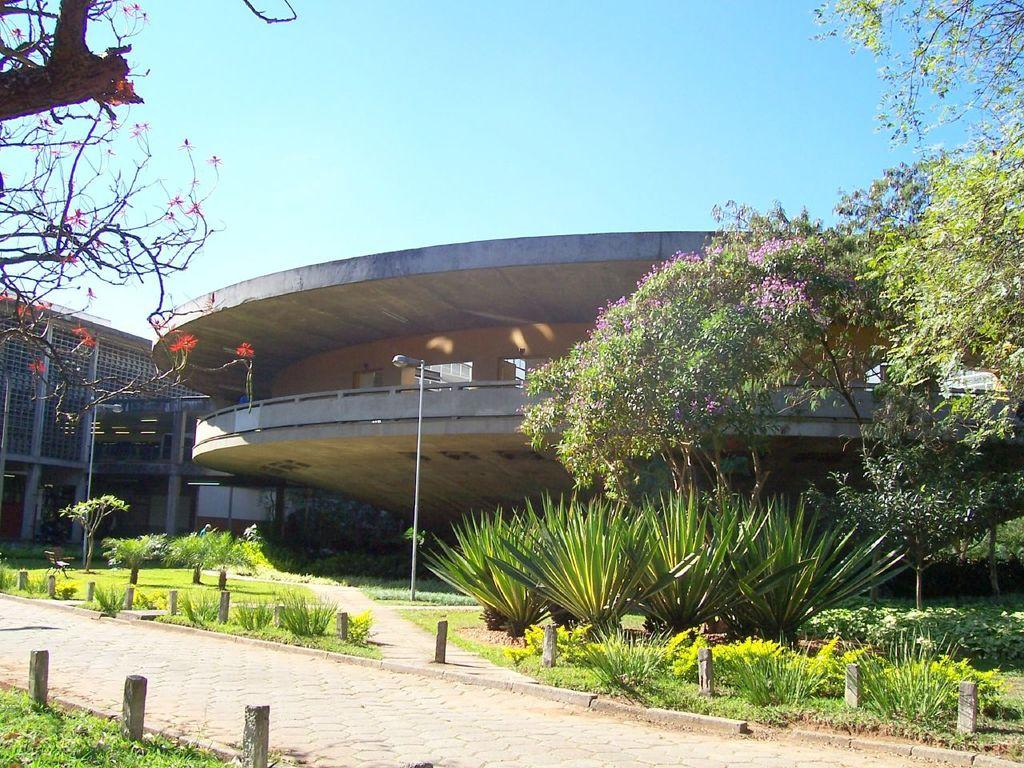What type of vegetation can be seen in the image? There is grass, plants, trees, and flowers in the image. What structures are present in the image? There is a pole and buildings in the image. What is visible in the background of the image? The sky is visible in the background of the image. What advice is the hydrant giving to the van in the image? There is no hydrant or van present in the image, so no such interaction can be observed. 